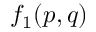Convert formula to latex. <formula><loc_0><loc_0><loc_500><loc_500>f _ { 1 } ( p , q )</formula> 